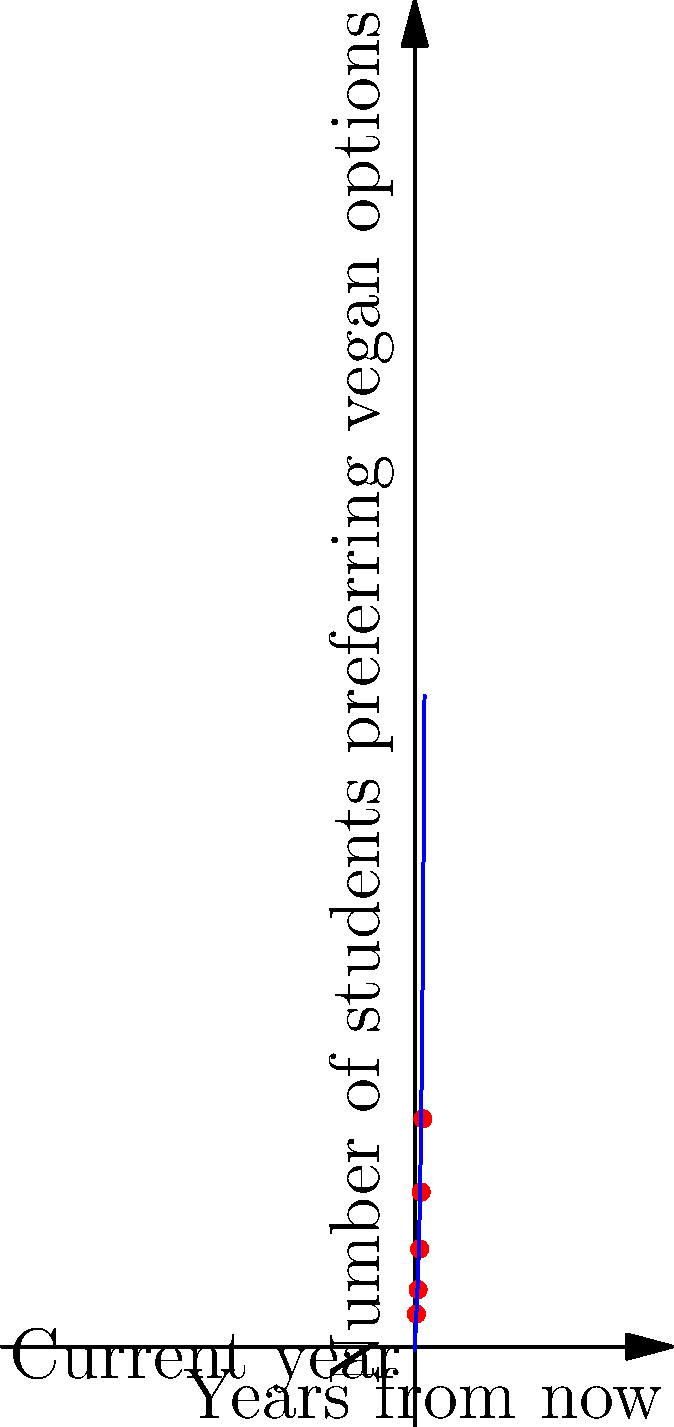As the student council representative responsible for catering, you've been tracking the number of students preferring vegan options over the past 5 years. The scatter plot shows the data points, and a polynomial function has been fitted to predict future trends. Using the given polynomial function $f(x) = 2x^3 - 5x^2 + 25x - 2$, where $x$ represents years from now and $f(x)$ represents the number of students preferring vegan options, estimate how many students will prefer vegan options 6 years from now (round to the nearest whole number). To solve this problem, we need to follow these steps:

1. Identify the polynomial function: $f(x) = 2x^3 - 5x^2 + 25x - 2$

2. Determine the value of $x$:
   - We want to predict 6 years from now, so $x = 6$

3. Substitute $x = 6$ into the function:
   $f(6) = 2(6^3) - 5(6^2) + 25(6) - 2$

4. Calculate each term:
   - $2(6^3) = 2(216) = 432$
   - $5(6^2) = 5(36) = 180$
   - $25(6) = 150$
   - $-2$ remains as is

5. Combine the terms:
   $f(6) = 432 - 180 + 150 - 2 = 400$

6. Round to the nearest whole number:
   400 is already a whole number, so no rounding is necessary.

Therefore, the polynomial model predicts that 400 students will prefer vegan options 6 years from now.
Answer: 400 students 